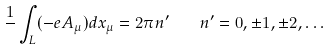<formula> <loc_0><loc_0><loc_500><loc_500>\frac { 1 } { } \int _ { L } ( - e A _ { \mu } ) d x _ { \mu } = 2 \pi n ^ { \prime } \quad n ^ { \prime } = 0 , \pm 1 , \pm 2 , \dots</formula> 